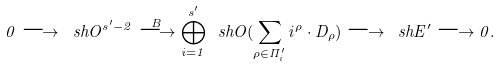<formula> <loc_0><loc_0><loc_500><loc_500>0 \longrightarrow \ s h { O } ^ { s ^ { \prime } - 2 } \overset { B } { \longrightarrow } \bigoplus _ { i = 1 } ^ { s ^ { \prime } } \ s h { O } ( \sum _ { \rho \in \Pi ^ { \prime } _ { i } } i ^ { \rho } \cdot D _ { \rho } ) \longrightarrow \ s h { E } ^ { \prime } \longrightarrow 0 .</formula> 